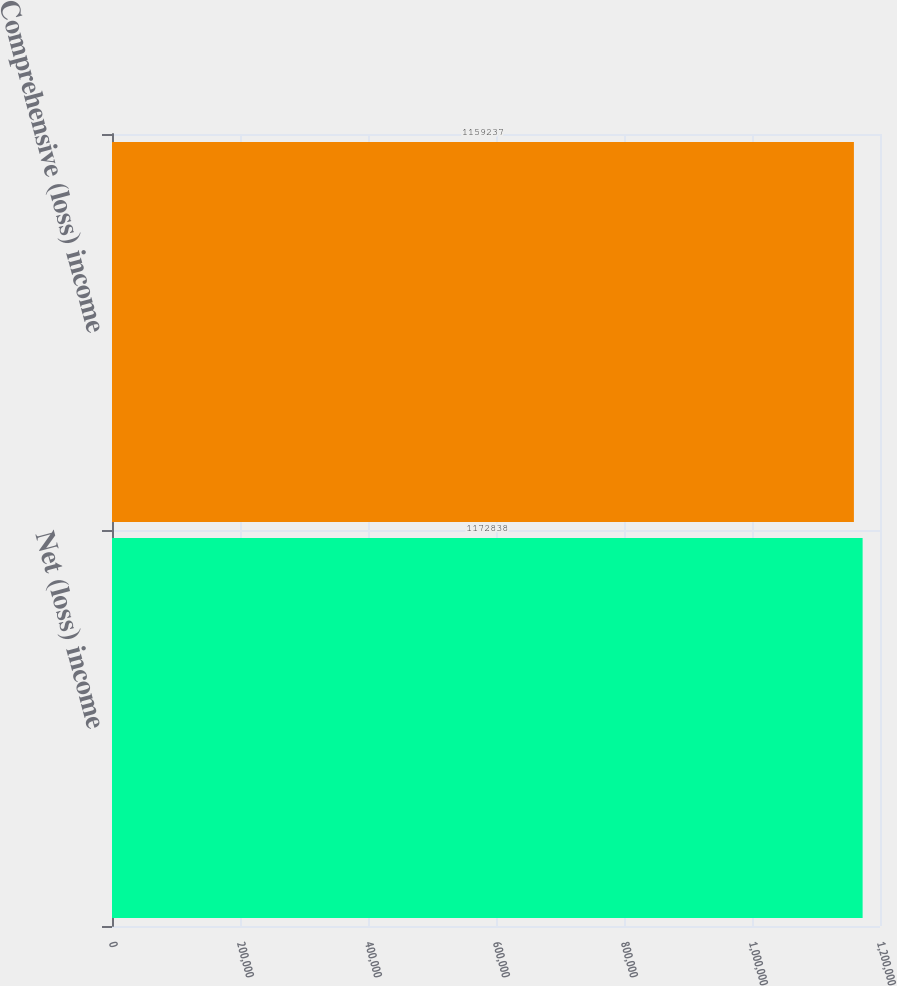<chart> <loc_0><loc_0><loc_500><loc_500><bar_chart><fcel>Net (loss) income<fcel>Comprehensive (loss) income<nl><fcel>1.17284e+06<fcel>1.15924e+06<nl></chart> 